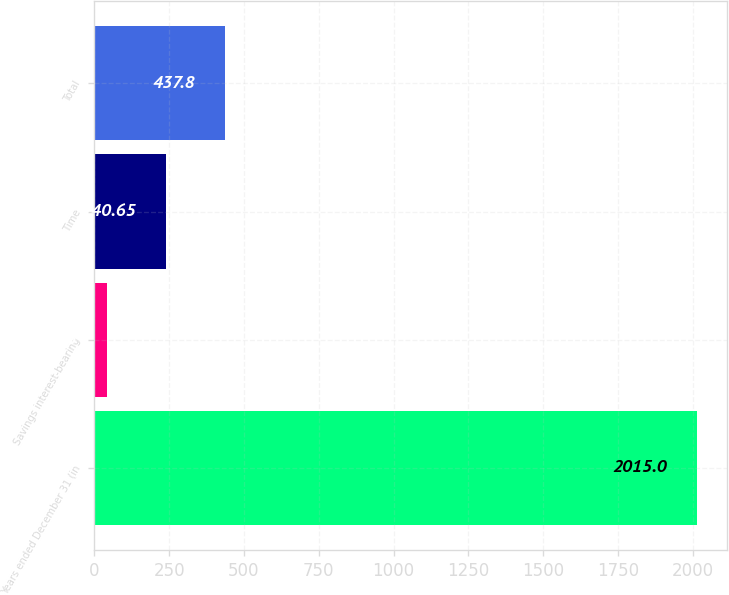Convert chart. <chart><loc_0><loc_0><loc_500><loc_500><bar_chart><fcel>Years ended December 31 (in<fcel>Savings interest-bearing<fcel>Time<fcel>Total<nl><fcel>2015<fcel>43.5<fcel>240.65<fcel>437.8<nl></chart> 